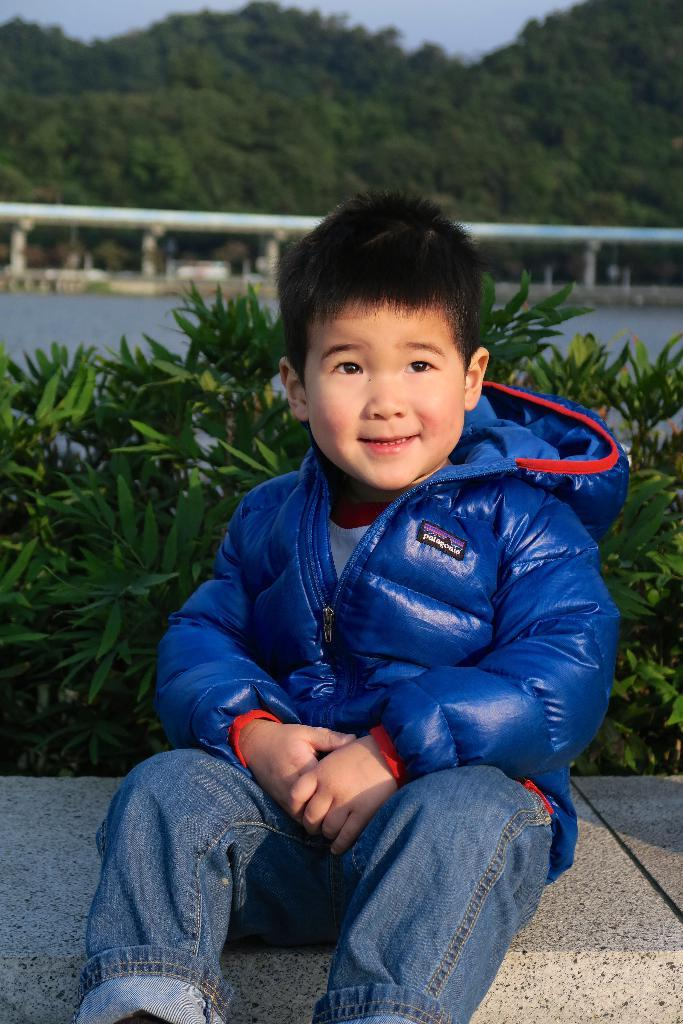What is the main subject of the image? There is a kid in the center of the image. What is the kid wearing? The kid is wearing a coat. What is the kid sitting on? The kid is sitting on a stone. What can be seen in the background of the image? There are plants, trees, a fence, and a road in the background of the image. What type of juice is the kid holding in the image? There is no juice present in the image; the kid is sitting on a stone and wearing a coat. 